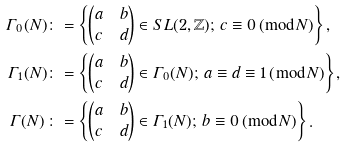Convert formula to latex. <formula><loc_0><loc_0><loc_500><loc_500>\varGamma _ { 0 } ( N ) & \colon = \left \{ \begin{pmatrix} a & b \\ c & d \end{pmatrix} \in S L ( 2 , \mathbb { Z } ) ; \, c \equiv 0 \, ( \bmod N ) \right \} , \\ \varGamma _ { 1 } ( N ) & \colon = \left \{ \begin{pmatrix} a & b \\ c & d \end{pmatrix} \in \varGamma _ { 0 } ( N ) ; \, a \equiv d \equiv 1 \, ( \bmod N ) \right \} , \\ \varGamma ( N ) \, & \colon = \left \{ \begin{pmatrix} a & b \\ c & d \end{pmatrix} \in \varGamma _ { 1 } ( N ) ; \, b \equiv 0 \, ( \bmod N ) \right \} .</formula> 